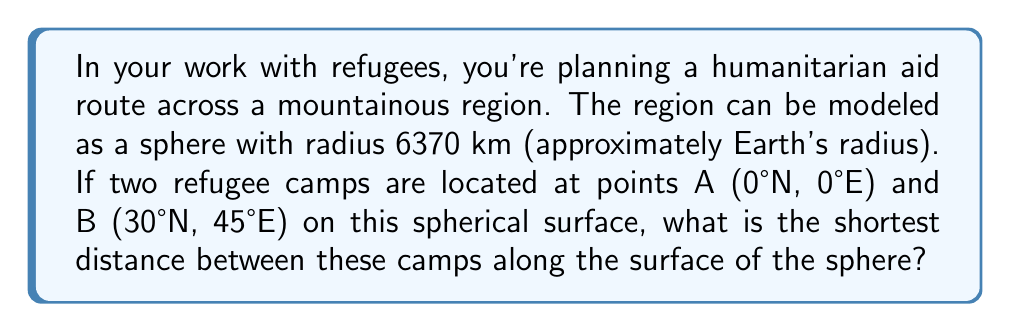Can you solve this math problem? To solve this problem, we'll use the concept of great circles on a sphere, which represent the shortest path between two points on a spherical surface. We'll follow these steps:

1) First, we need to convert the given coordinates to radians:
   Point A: (0°, 0°) = (0, 0) radians
   Point B: (30°N, 45°E) = ($\frac{\pi}{6}$, $\frac{\pi}{4}$) radians

2) We'll use the great circle distance formula:
   $$d = R \cdot \arccos(\sin\phi_1 \sin\phi_2 + \cos\phi_1 \cos\phi_2 \cos(\lambda_2 - \lambda_1))$$
   
   Where:
   $R$ is the radius of the sphere
   $\phi_1$, $\lambda_1$ are the latitude and longitude of point A
   $\phi_2$, $\lambda_2$ are the latitude and longitude of point B

3) Substituting our values:
   $$d = 6370 \cdot \arccos(\sin(0) \sin(\frac{\pi}{6}) + \cos(0) \cos(\frac{\pi}{6}) \cos(\frac{\pi}{4} - 0))$$

4) Simplifying:
   $$d = 6370 \cdot \arccos(0 + \cos(\frac{\pi}{6}) \cos(\frac{\pi}{4}))$$
   $$d = 6370 \cdot \arccos(\frac{\sqrt{3}}{2} \cdot \frac{\sqrt{2}}{2})$$
   $$d = 6370 \cdot \arccos(\frac{\sqrt{6}}{4})$$

5) Calculating the final result:
   $$d \approx 6370 \cdot 0.8410 \approx 5357.17 \text{ km}$$

Therefore, the shortest distance between the two refugee camps along the surface of the sphere is approximately 5357.17 km.
Answer: 5357.17 km 